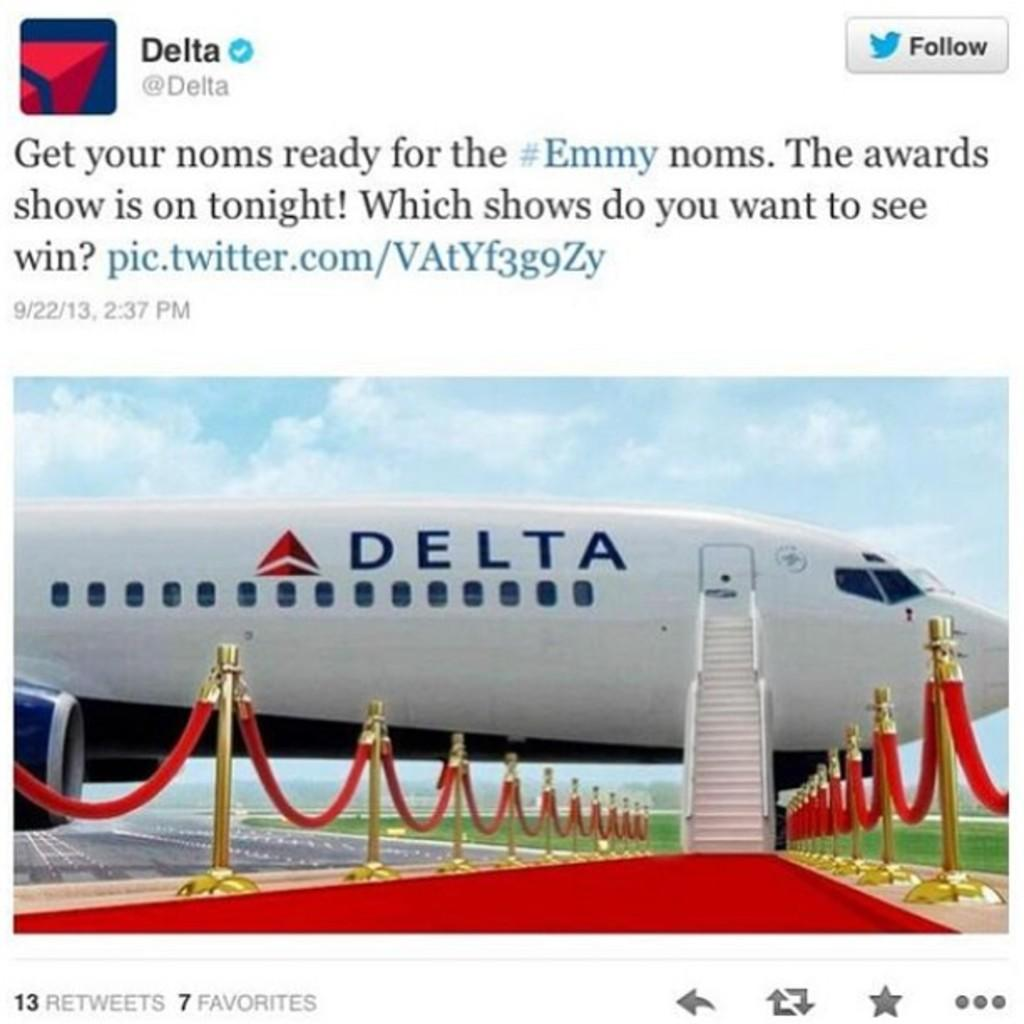<image>
Write a terse but informative summary of the picture. A tweet by Delta airlines showing a commercial jet with a red carpet leading to it. 